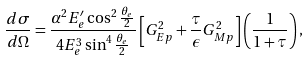<formula> <loc_0><loc_0><loc_500><loc_500>\frac { d \sigma } { d \Omega } = \frac { { \alpha } ^ { 2 } E ^ { \prime } _ { e } \cos ^ { 2 } \frac { \theta _ { e } } { 2 } } { 4 E _ { e } ^ { 3 } \sin ^ { 4 } \frac { \theta _ { e } } { 2 } } \left [ G _ { E p } ^ { 2 } + \frac { \tau } { \epsilon } G _ { M p } ^ { 2 } \right ] \left ( \frac { 1 } { 1 + \tau } \right ) ,</formula> 